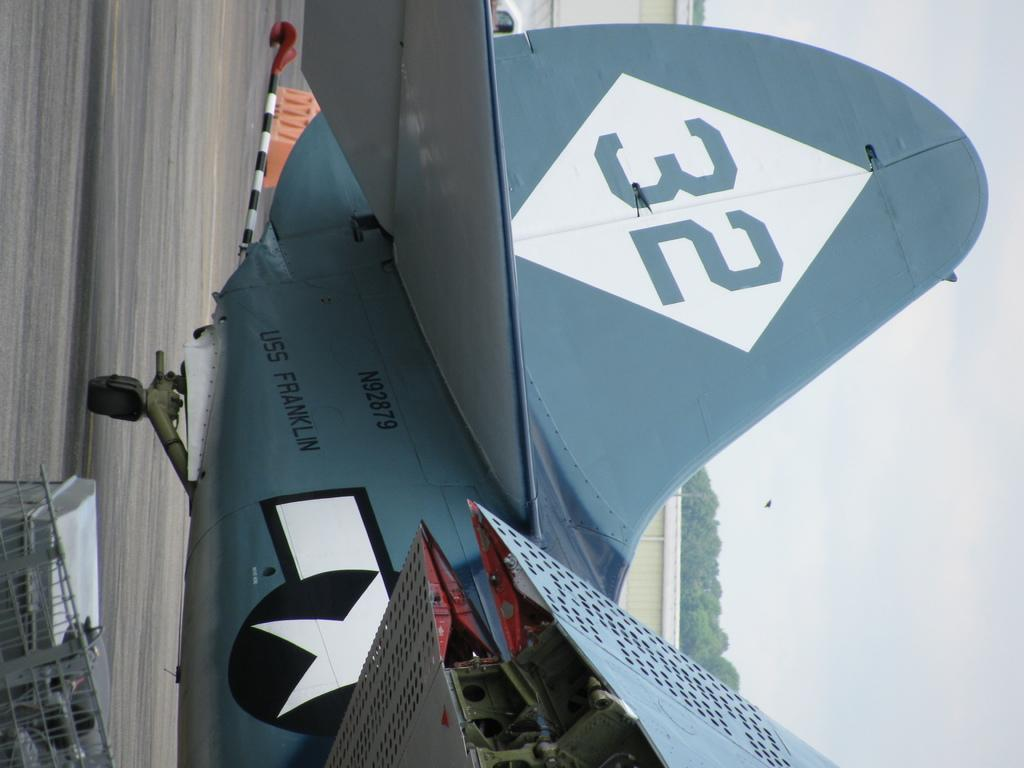<image>
Describe the image concisely. a plane that says '32' on the side of it 